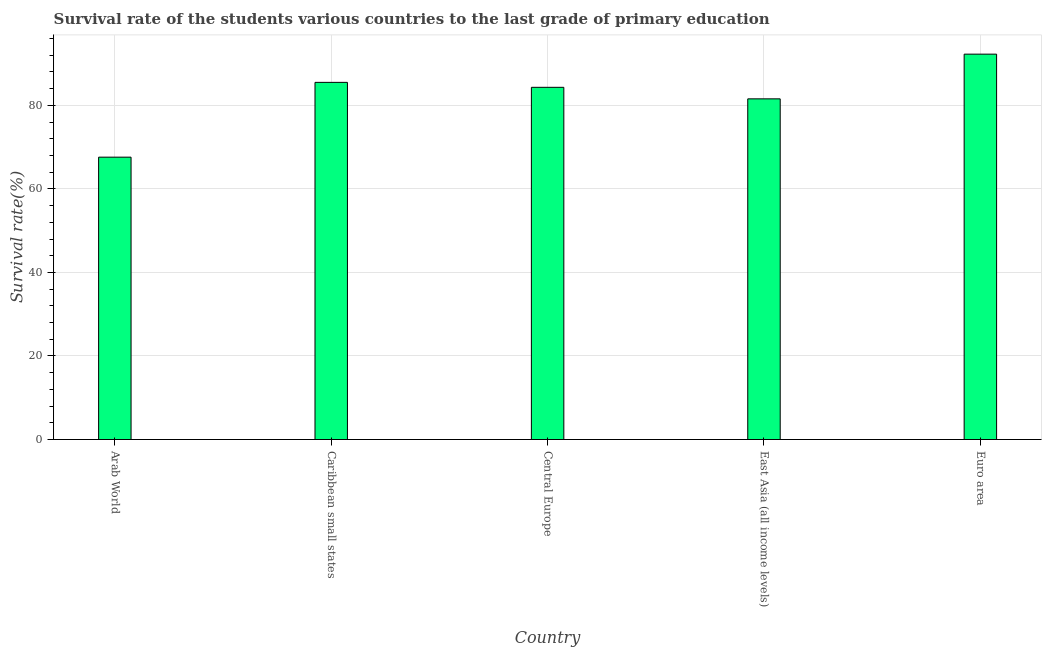What is the title of the graph?
Your answer should be very brief. Survival rate of the students various countries to the last grade of primary education. What is the label or title of the X-axis?
Provide a short and direct response. Country. What is the label or title of the Y-axis?
Keep it short and to the point. Survival rate(%). What is the survival rate in primary education in Euro area?
Your answer should be compact. 92.27. Across all countries, what is the maximum survival rate in primary education?
Make the answer very short. 92.27. Across all countries, what is the minimum survival rate in primary education?
Make the answer very short. 67.61. In which country was the survival rate in primary education minimum?
Your response must be concise. Arab World. What is the sum of the survival rate in primary education?
Ensure brevity in your answer.  411.28. What is the difference between the survival rate in primary education in Arab World and Caribbean small states?
Provide a short and direct response. -17.91. What is the average survival rate in primary education per country?
Offer a terse response. 82.26. What is the median survival rate in primary education?
Provide a succinct answer. 84.33. What is the ratio of the survival rate in primary education in Arab World to that in Euro area?
Provide a short and direct response. 0.73. Is the survival rate in primary education in Caribbean small states less than that in East Asia (all income levels)?
Your answer should be compact. No. Is the difference between the survival rate in primary education in Caribbean small states and East Asia (all income levels) greater than the difference between any two countries?
Provide a succinct answer. No. What is the difference between the highest and the second highest survival rate in primary education?
Your answer should be very brief. 6.76. What is the difference between the highest and the lowest survival rate in primary education?
Your answer should be compact. 24.67. In how many countries, is the survival rate in primary education greater than the average survival rate in primary education taken over all countries?
Provide a succinct answer. 3. Are all the bars in the graph horizontal?
Offer a very short reply. No. How many countries are there in the graph?
Your answer should be compact. 5. What is the Survival rate(%) of Arab World?
Give a very brief answer. 67.61. What is the Survival rate(%) in Caribbean small states?
Keep it short and to the point. 85.51. What is the Survival rate(%) in Central Europe?
Offer a terse response. 84.33. What is the Survival rate(%) in East Asia (all income levels)?
Your answer should be very brief. 81.57. What is the Survival rate(%) in Euro area?
Your answer should be very brief. 92.27. What is the difference between the Survival rate(%) in Arab World and Caribbean small states?
Make the answer very short. -17.91. What is the difference between the Survival rate(%) in Arab World and Central Europe?
Ensure brevity in your answer.  -16.72. What is the difference between the Survival rate(%) in Arab World and East Asia (all income levels)?
Your answer should be compact. -13.96. What is the difference between the Survival rate(%) in Arab World and Euro area?
Your response must be concise. -24.67. What is the difference between the Survival rate(%) in Caribbean small states and Central Europe?
Your response must be concise. 1.19. What is the difference between the Survival rate(%) in Caribbean small states and East Asia (all income levels)?
Your answer should be compact. 3.95. What is the difference between the Survival rate(%) in Caribbean small states and Euro area?
Make the answer very short. -6.76. What is the difference between the Survival rate(%) in Central Europe and East Asia (all income levels)?
Your response must be concise. 2.76. What is the difference between the Survival rate(%) in Central Europe and Euro area?
Ensure brevity in your answer.  -7.94. What is the difference between the Survival rate(%) in East Asia (all income levels) and Euro area?
Keep it short and to the point. -10.7. What is the ratio of the Survival rate(%) in Arab World to that in Caribbean small states?
Your answer should be very brief. 0.79. What is the ratio of the Survival rate(%) in Arab World to that in Central Europe?
Provide a short and direct response. 0.8. What is the ratio of the Survival rate(%) in Arab World to that in East Asia (all income levels)?
Your answer should be compact. 0.83. What is the ratio of the Survival rate(%) in Arab World to that in Euro area?
Your response must be concise. 0.73. What is the ratio of the Survival rate(%) in Caribbean small states to that in East Asia (all income levels)?
Your answer should be very brief. 1.05. What is the ratio of the Survival rate(%) in Caribbean small states to that in Euro area?
Your response must be concise. 0.93. What is the ratio of the Survival rate(%) in Central Europe to that in East Asia (all income levels)?
Offer a terse response. 1.03. What is the ratio of the Survival rate(%) in Central Europe to that in Euro area?
Keep it short and to the point. 0.91. What is the ratio of the Survival rate(%) in East Asia (all income levels) to that in Euro area?
Make the answer very short. 0.88. 